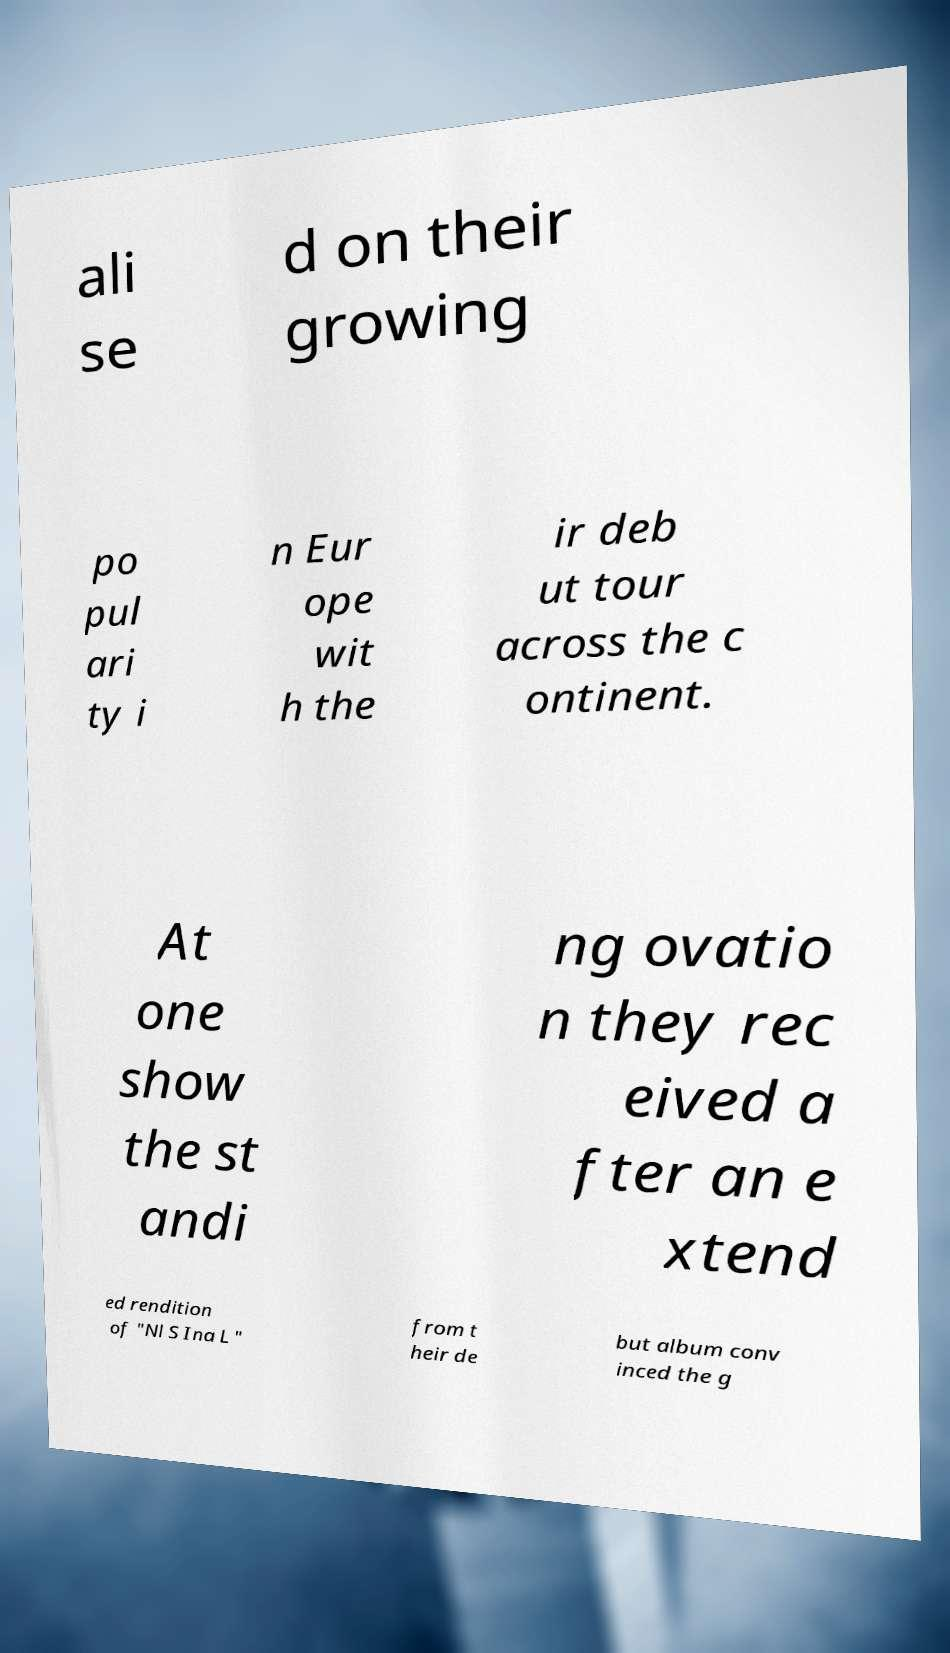For documentation purposes, I need the text within this image transcribed. Could you provide that? ali se d on their growing po pul ari ty i n Eur ope wit h the ir deb ut tour across the c ontinent. At one show the st andi ng ovatio n they rec eived a fter an e xtend ed rendition of "Nl S Ina L " from t heir de but album conv inced the g 